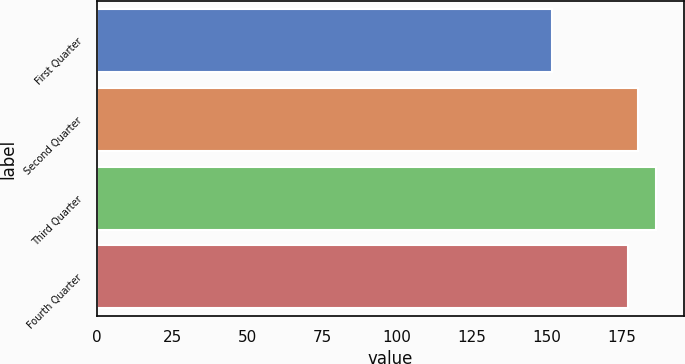<chart> <loc_0><loc_0><loc_500><loc_500><bar_chart><fcel>First Quarter<fcel>Second Quarter<fcel>Third Quarter<fcel>Fourth Quarter<nl><fcel>151.78<fcel>180.42<fcel>186.19<fcel>176.98<nl></chart> 